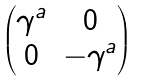<formula> <loc_0><loc_0><loc_500><loc_500>\begin{pmatrix} \gamma ^ { a } & 0 \\ 0 & - \gamma ^ { a } \end{pmatrix}</formula> 